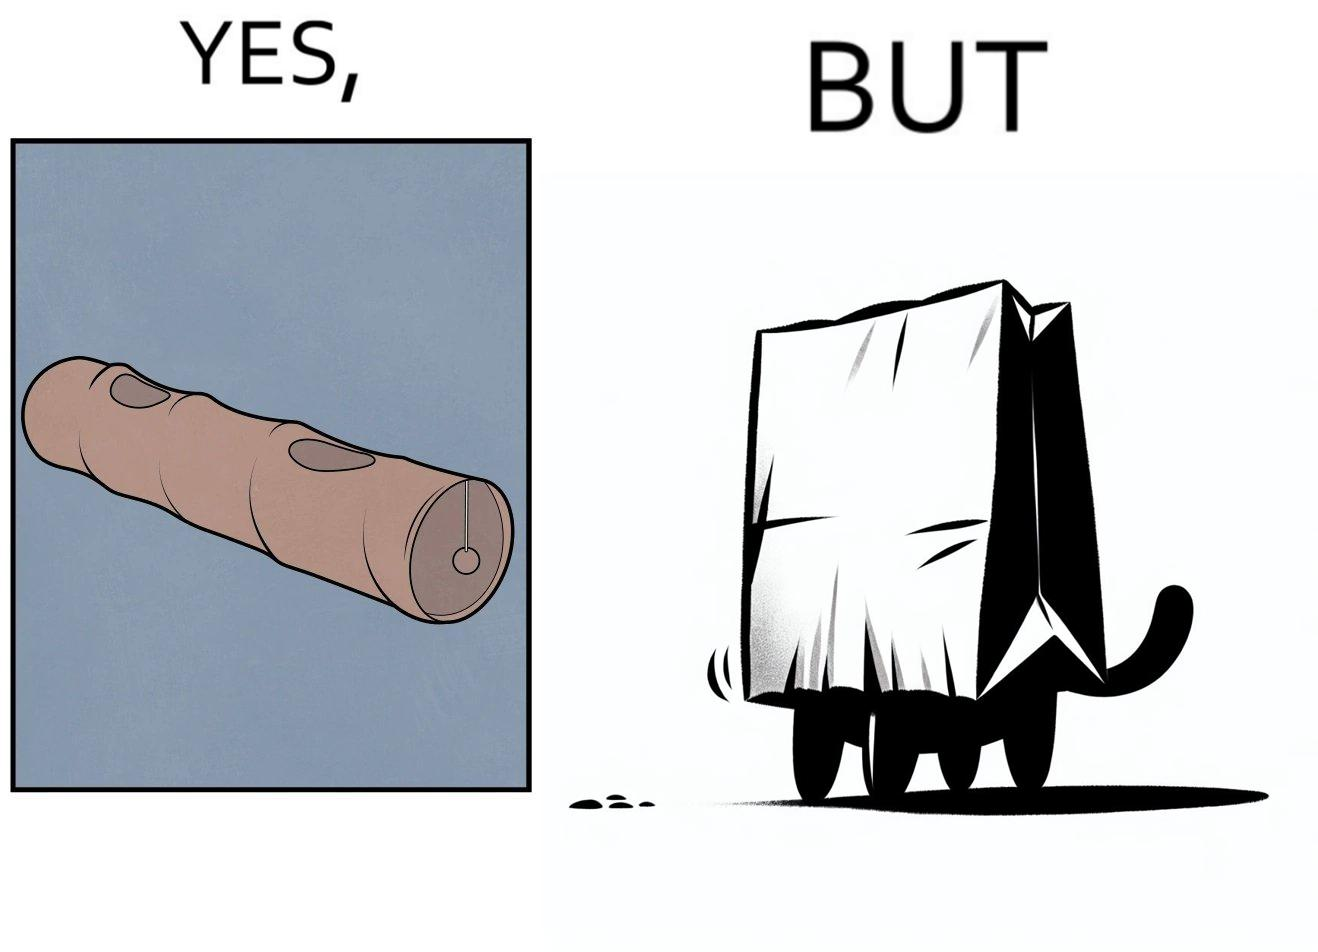Would you classify this image as satirical? Yes, this image is satirical. 